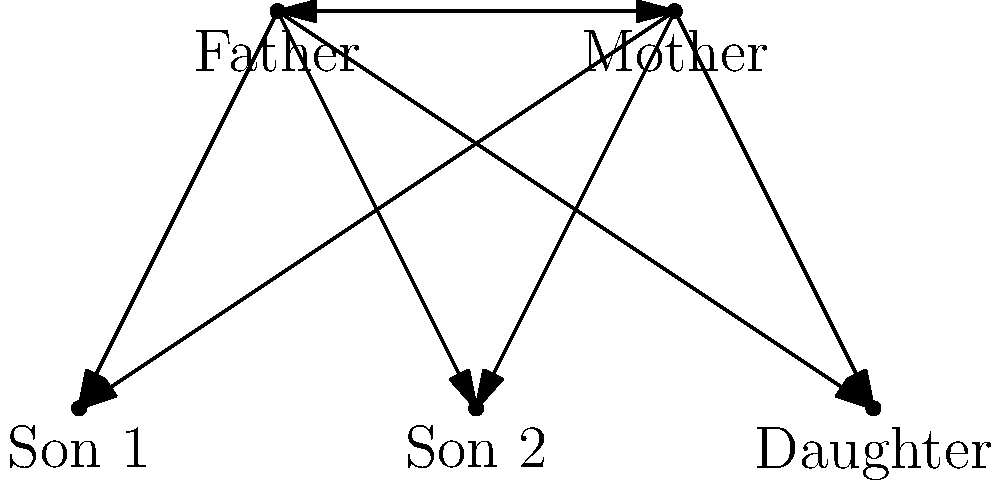According to the complementarian view of biblical family structure, which relationship in the diagram represents the concept of "headship" as described in Ephesians 5:23? To answer this question, we need to consider the complementarian interpretation of biblical family structure:

1. Complementarianism teaches that men and women have different but complementary roles in marriage, family, and church leadership.

2. Ephesians 5:23 states, "For the husband is the head of the wife as Christ is the head of the church, his body, of which he is the Savior."

3. In the complementarian view, this verse establishes a hierarchical structure within the family, with the husband as the spiritual leader or "head" of the household.

4. Looking at the diagram, we see a family structure with a father, mother, and three children (two sons and a daughter).

5. The relationship between the father and mother is represented by a double-headed arrow, indicating a connection between them.

6. According to the complementarian interpretation of Ephesians 5:23, the concept of "headship" would be represented by the father's position in relation to the mother.

7. Therefore, the relationship that represents the concept of "headship" in this diagram is the one between the father and the mother, with the father being the "head" of the family.
Answer: Father-Mother relationship 